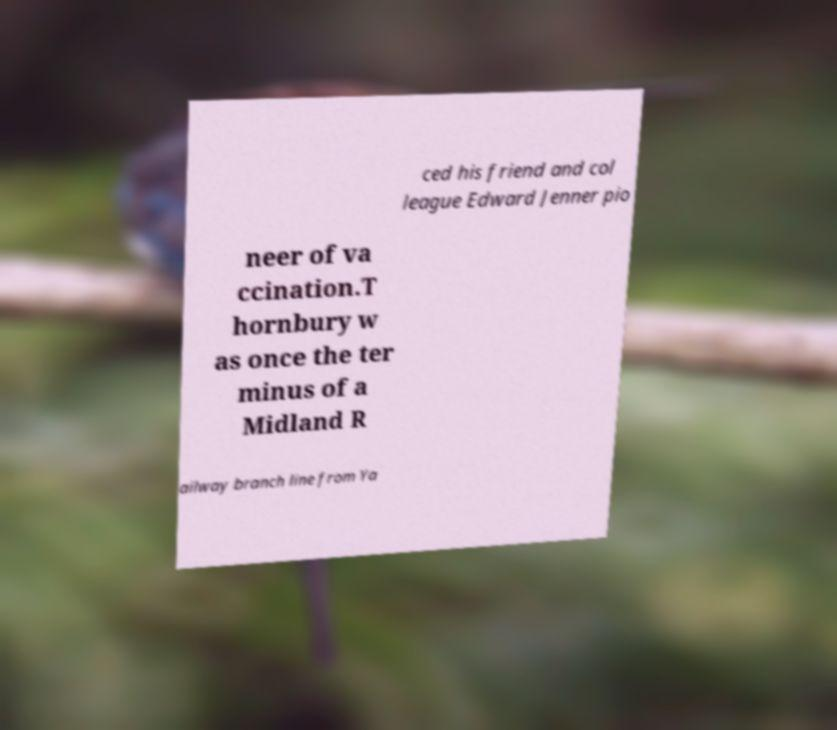Could you assist in decoding the text presented in this image and type it out clearly? ced his friend and col league Edward Jenner pio neer of va ccination.T hornbury w as once the ter minus of a Midland R ailway branch line from Ya 